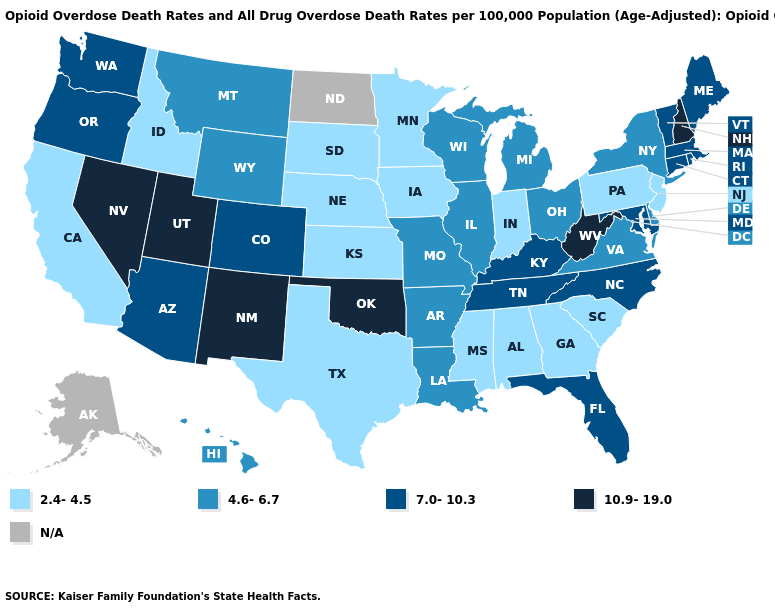Does Nebraska have the lowest value in the USA?
Give a very brief answer. Yes. What is the value of Ohio?
Concise answer only. 4.6-6.7. What is the value of Florida?
Quick response, please. 7.0-10.3. Among the states that border Idaho , does Wyoming have the lowest value?
Quick response, please. Yes. Name the states that have a value in the range N/A?
Answer briefly. Alaska, North Dakota. What is the lowest value in the USA?
Short answer required. 2.4-4.5. Does Georgia have the lowest value in the USA?
Write a very short answer. Yes. Among the states that border North Dakota , which have the highest value?
Short answer required. Montana. Which states have the lowest value in the West?
Keep it brief. California, Idaho. What is the lowest value in states that border Mississippi?
Keep it brief. 2.4-4.5. Does the first symbol in the legend represent the smallest category?
Give a very brief answer. Yes. Which states have the lowest value in the USA?
Quick response, please. Alabama, California, Georgia, Idaho, Indiana, Iowa, Kansas, Minnesota, Mississippi, Nebraska, New Jersey, Pennsylvania, South Carolina, South Dakota, Texas. What is the lowest value in the USA?
Keep it brief. 2.4-4.5. Among the states that border Connecticut , does New York have the highest value?
Answer briefly. No. Does New Mexico have the lowest value in the West?
Quick response, please. No. 